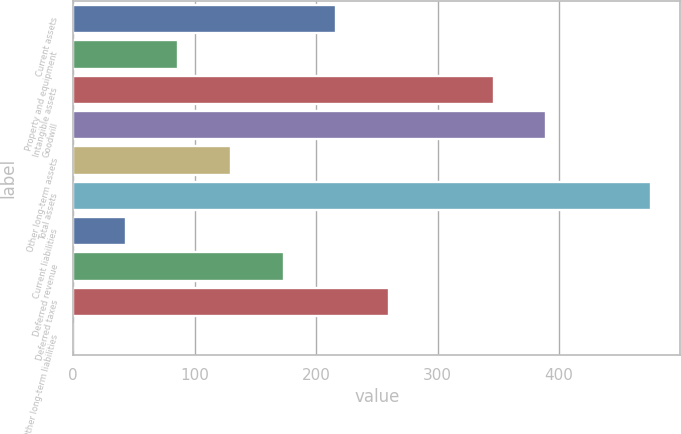Convert chart to OTSL. <chart><loc_0><loc_0><loc_500><loc_500><bar_chart><fcel>Current assets<fcel>Property and equipment<fcel>Intangible assets<fcel>Goodwill<fcel>Other long-term assets<fcel>Total assets<fcel>Current liabilities<fcel>Deferred revenue<fcel>Deferred taxes<fcel>Other long-term liabilities<nl><fcel>216.45<fcel>86.64<fcel>346.26<fcel>389.53<fcel>129.91<fcel>476.07<fcel>43.37<fcel>173.18<fcel>259.72<fcel>0.1<nl></chart> 